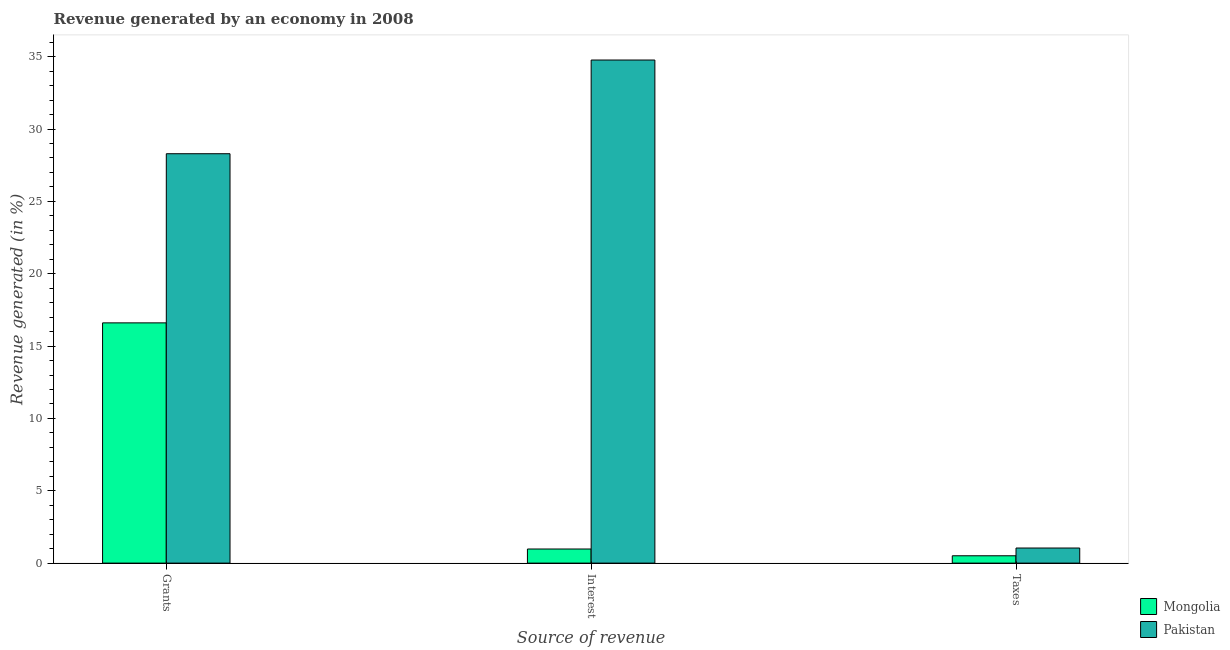How many groups of bars are there?
Offer a terse response. 3. How many bars are there on the 3rd tick from the left?
Give a very brief answer. 2. How many bars are there on the 1st tick from the right?
Provide a succinct answer. 2. What is the label of the 3rd group of bars from the left?
Your answer should be compact. Taxes. What is the percentage of revenue generated by taxes in Pakistan?
Your response must be concise. 1.04. Across all countries, what is the maximum percentage of revenue generated by taxes?
Make the answer very short. 1.04. Across all countries, what is the minimum percentage of revenue generated by interest?
Provide a succinct answer. 0.97. In which country was the percentage of revenue generated by grants maximum?
Give a very brief answer. Pakistan. In which country was the percentage of revenue generated by taxes minimum?
Your answer should be very brief. Mongolia. What is the total percentage of revenue generated by grants in the graph?
Give a very brief answer. 44.9. What is the difference between the percentage of revenue generated by taxes in Pakistan and that in Mongolia?
Offer a terse response. 0.54. What is the difference between the percentage of revenue generated by taxes in Mongolia and the percentage of revenue generated by interest in Pakistan?
Provide a short and direct response. -34.26. What is the average percentage of revenue generated by interest per country?
Your response must be concise. 17.87. What is the difference between the percentage of revenue generated by taxes and percentage of revenue generated by grants in Mongolia?
Ensure brevity in your answer.  -16.1. What is the ratio of the percentage of revenue generated by interest in Mongolia to that in Pakistan?
Your answer should be compact. 0.03. Is the percentage of revenue generated by taxes in Mongolia less than that in Pakistan?
Ensure brevity in your answer.  Yes. Is the difference between the percentage of revenue generated by interest in Pakistan and Mongolia greater than the difference between the percentage of revenue generated by taxes in Pakistan and Mongolia?
Your answer should be very brief. Yes. What is the difference between the highest and the second highest percentage of revenue generated by grants?
Your answer should be very brief. 11.69. What is the difference between the highest and the lowest percentage of revenue generated by interest?
Provide a short and direct response. 33.79. In how many countries, is the percentage of revenue generated by grants greater than the average percentage of revenue generated by grants taken over all countries?
Give a very brief answer. 1. What does the 1st bar from the left in Interest represents?
Your response must be concise. Mongolia. What does the 1st bar from the right in Grants represents?
Provide a short and direct response. Pakistan. Is it the case that in every country, the sum of the percentage of revenue generated by grants and percentage of revenue generated by interest is greater than the percentage of revenue generated by taxes?
Your response must be concise. Yes. How many bars are there?
Your response must be concise. 6. How many countries are there in the graph?
Give a very brief answer. 2. Are the values on the major ticks of Y-axis written in scientific E-notation?
Provide a short and direct response. No. Where does the legend appear in the graph?
Offer a terse response. Bottom right. How many legend labels are there?
Your answer should be very brief. 2. How are the legend labels stacked?
Give a very brief answer. Vertical. What is the title of the graph?
Make the answer very short. Revenue generated by an economy in 2008. Does "Turkey" appear as one of the legend labels in the graph?
Your response must be concise. No. What is the label or title of the X-axis?
Offer a very short reply. Source of revenue. What is the label or title of the Y-axis?
Your response must be concise. Revenue generated (in %). What is the Revenue generated (in %) of Mongolia in Grants?
Ensure brevity in your answer.  16.6. What is the Revenue generated (in %) of Pakistan in Grants?
Keep it short and to the point. 28.29. What is the Revenue generated (in %) of Mongolia in Interest?
Offer a terse response. 0.97. What is the Revenue generated (in %) in Pakistan in Interest?
Your answer should be compact. 34.77. What is the Revenue generated (in %) of Mongolia in Taxes?
Your response must be concise. 0.51. What is the Revenue generated (in %) in Pakistan in Taxes?
Your answer should be very brief. 1.04. Across all Source of revenue, what is the maximum Revenue generated (in %) of Mongolia?
Provide a short and direct response. 16.6. Across all Source of revenue, what is the maximum Revenue generated (in %) in Pakistan?
Offer a very short reply. 34.77. Across all Source of revenue, what is the minimum Revenue generated (in %) in Mongolia?
Make the answer very short. 0.51. Across all Source of revenue, what is the minimum Revenue generated (in %) of Pakistan?
Offer a terse response. 1.04. What is the total Revenue generated (in %) in Mongolia in the graph?
Your response must be concise. 18.09. What is the total Revenue generated (in %) of Pakistan in the graph?
Provide a short and direct response. 64.11. What is the difference between the Revenue generated (in %) in Mongolia in Grants and that in Interest?
Your answer should be very brief. 15.63. What is the difference between the Revenue generated (in %) in Pakistan in Grants and that in Interest?
Offer a very short reply. -6.48. What is the difference between the Revenue generated (in %) in Mongolia in Grants and that in Taxes?
Provide a succinct answer. 16.1. What is the difference between the Revenue generated (in %) in Pakistan in Grants and that in Taxes?
Keep it short and to the point. 27.25. What is the difference between the Revenue generated (in %) in Mongolia in Interest and that in Taxes?
Your answer should be compact. 0.47. What is the difference between the Revenue generated (in %) of Pakistan in Interest and that in Taxes?
Provide a short and direct response. 33.73. What is the difference between the Revenue generated (in %) in Mongolia in Grants and the Revenue generated (in %) in Pakistan in Interest?
Ensure brevity in your answer.  -18.17. What is the difference between the Revenue generated (in %) in Mongolia in Grants and the Revenue generated (in %) in Pakistan in Taxes?
Give a very brief answer. 15.56. What is the difference between the Revenue generated (in %) of Mongolia in Interest and the Revenue generated (in %) of Pakistan in Taxes?
Provide a succinct answer. -0.07. What is the average Revenue generated (in %) of Mongolia per Source of revenue?
Your answer should be compact. 6.03. What is the average Revenue generated (in %) in Pakistan per Source of revenue?
Your answer should be very brief. 21.37. What is the difference between the Revenue generated (in %) of Mongolia and Revenue generated (in %) of Pakistan in Grants?
Provide a succinct answer. -11.69. What is the difference between the Revenue generated (in %) in Mongolia and Revenue generated (in %) in Pakistan in Interest?
Your answer should be compact. -33.79. What is the difference between the Revenue generated (in %) of Mongolia and Revenue generated (in %) of Pakistan in Taxes?
Offer a terse response. -0.54. What is the ratio of the Revenue generated (in %) in Mongolia in Grants to that in Interest?
Give a very brief answer. 17.04. What is the ratio of the Revenue generated (in %) of Pakistan in Grants to that in Interest?
Provide a succinct answer. 0.81. What is the ratio of the Revenue generated (in %) in Mongolia in Grants to that in Taxes?
Your answer should be compact. 32.72. What is the ratio of the Revenue generated (in %) in Pakistan in Grants to that in Taxes?
Offer a very short reply. 27.13. What is the ratio of the Revenue generated (in %) in Mongolia in Interest to that in Taxes?
Ensure brevity in your answer.  1.92. What is the ratio of the Revenue generated (in %) in Pakistan in Interest to that in Taxes?
Ensure brevity in your answer.  33.34. What is the difference between the highest and the second highest Revenue generated (in %) in Mongolia?
Your answer should be very brief. 15.63. What is the difference between the highest and the second highest Revenue generated (in %) of Pakistan?
Your answer should be very brief. 6.48. What is the difference between the highest and the lowest Revenue generated (in %) of Mongolia?
Ensure brevity in your answer.  16.1. What is the difference between the highest and the lowest Revenue generated (in %) in Pakistan?
Offer a terse response. 33.73. 